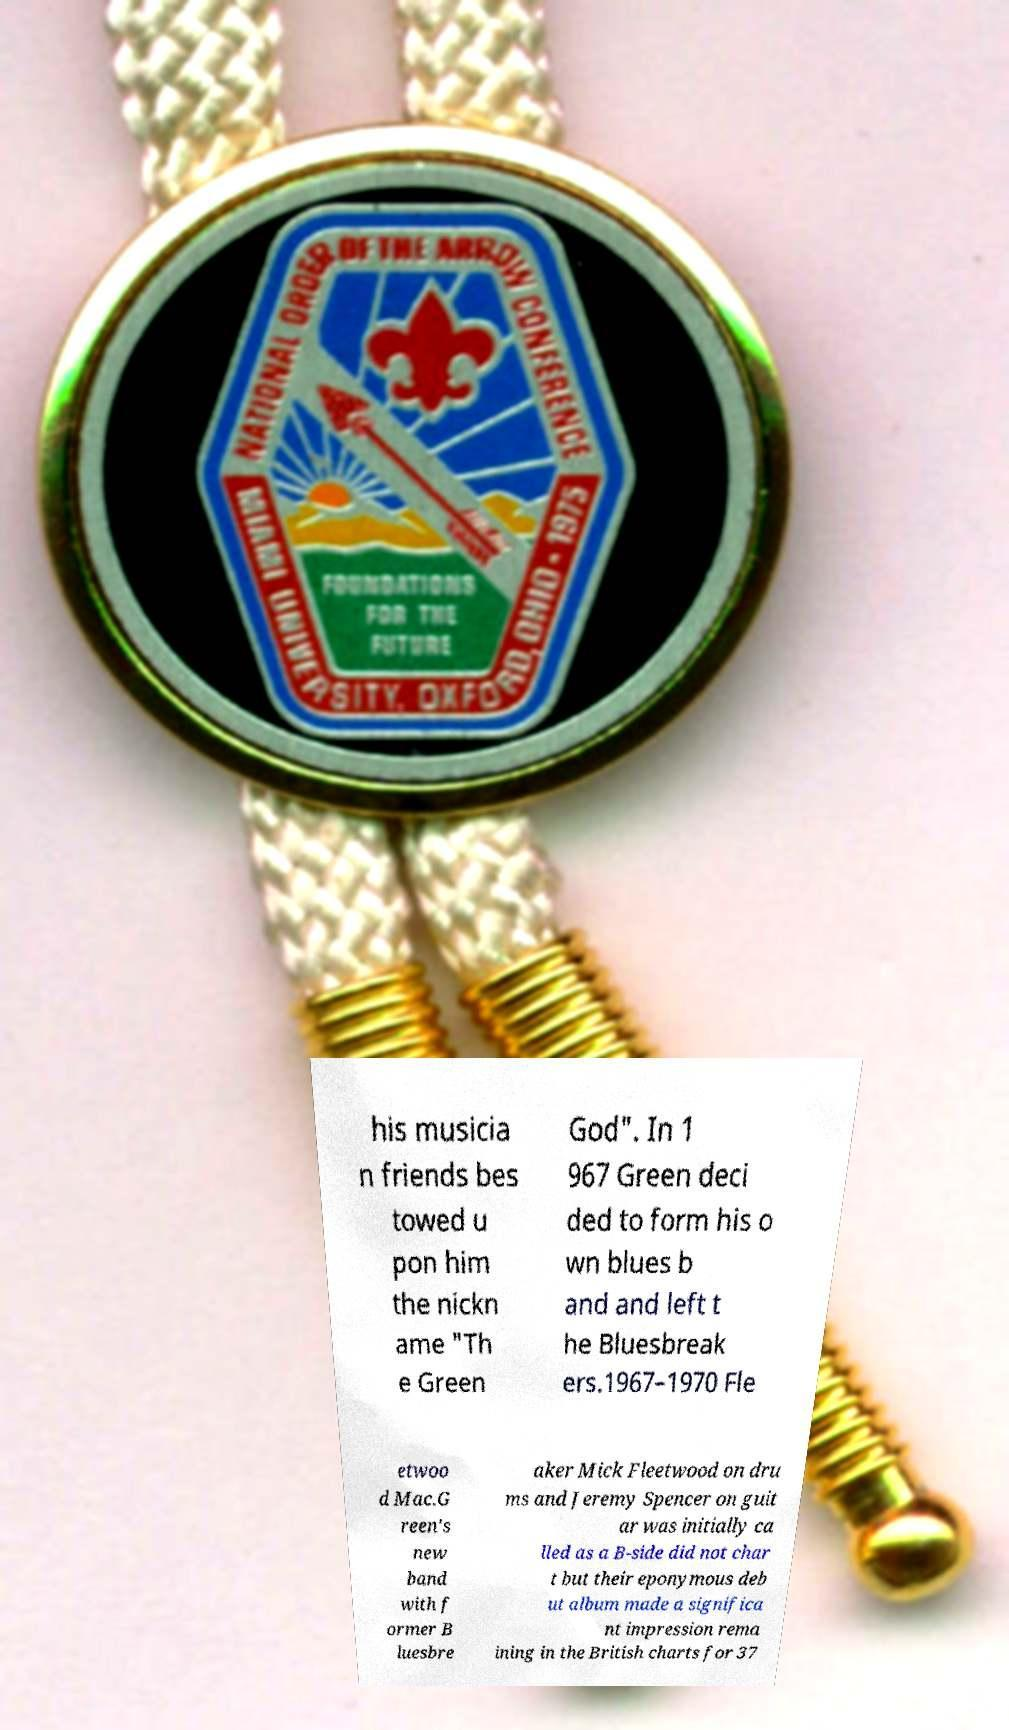What messages or text are displayed in this image? I need them in a readable, typed format. his musicia n friends bes towed u pon him the nickn ame "Th e Green God". In 1 967 Green deci ded to form his o wn blues b and and left t he Bluesbreak ers.1967–1970 Fle etwoo d Mac.G reen's new band with f ormer B luesbre aker Mick Fleetwood on dru ms and Jeremy Spencer on guit ar was initially ca lled as a B-side did not char t but their eponymous deb ut album made a significa nt impression rema ining in the British charts for 37 